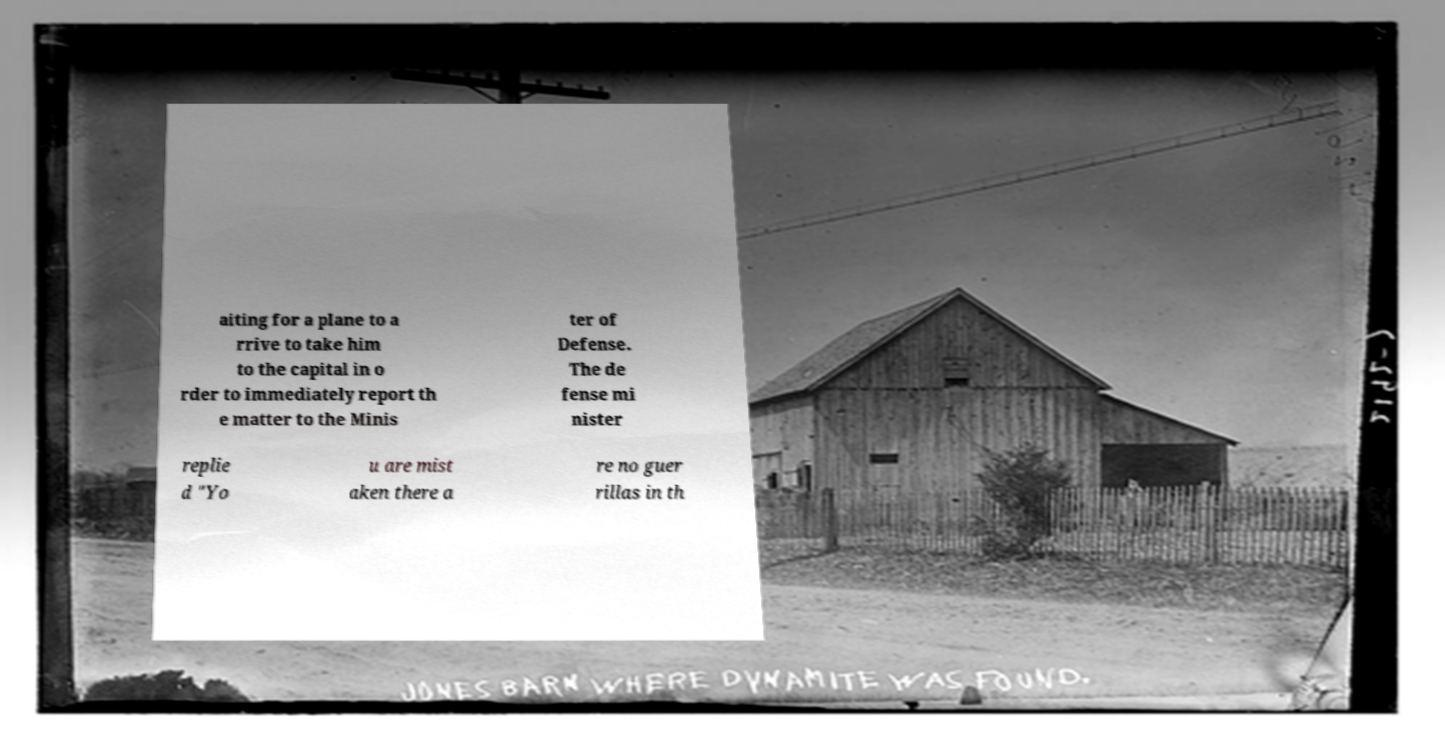There's text embedded in this image that I need extracted. Can you transcribe it verbatim? aiting for a plane to a rrive to take him to the capital in o rder to immediately report th e matter to the Minis ter of Defense. The de fense mi nister replie d "Yo u are mist aken there a re no guer rillas in th 